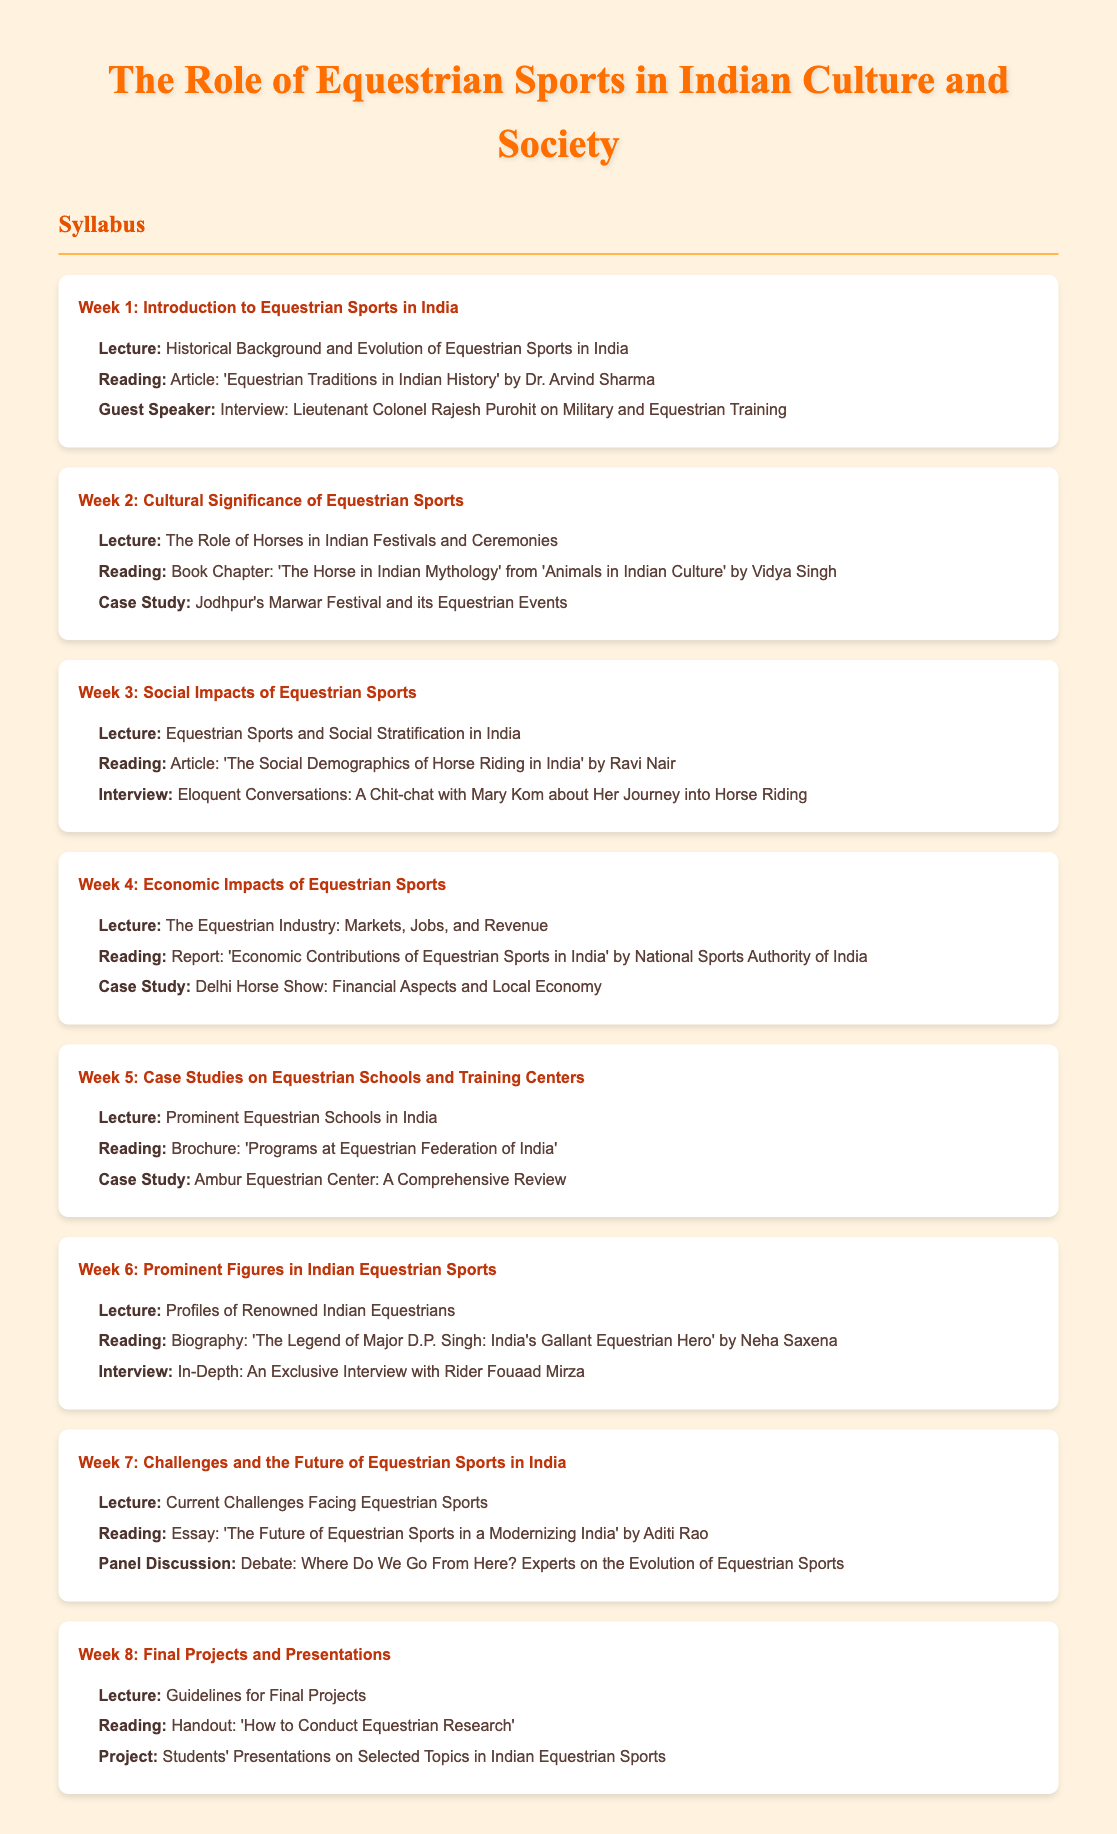What is the title of the syllabus? The title of the syllabus is prominently displayed at the beginning of the document, stating its main focus.
Answer: The Role of Equestrian Sports in Indian Culture and Society Who is the guest speaker in Week 1? The document lists a guest speaker for Week 1, highlighting individuals with expertise in equestrian sports.
Answer: Lieutenant Colonel Rajesh Purohit What is the case study in Week 2? A specific case study is provided in Week 2, showcasing an event relevant to equestrian sports in India.
Answer: Jodhpur's Marwar Festival and its Equestrian Events How many weeks are covered in the syllabus? The syllabus is organized into weeks, and the total number of weeks is explicitly stated.
Answer: 8 Which article is assigned in Week 3? The syllabus references a specific article related to social impacts in Week 3 that students are required to read.
Answer: The Social Demographics of Horse Riding in India What is the focus of Week 4's lecture? The theme of the lecture for Week 4 is outlined, indicating the economic aspects of equestrian sports.
Answer: The Equestrian Industry: Markets, Jobs, and Revenue Who is interviewed in Week 6? An interview subject is highlighted in Week 6, providing insight into the experiences of a notable figure in the field.
Answer: Rider Fouaad Mirza What reading material is provided for Week 7? A specific essay is mentioned that students will read in Week 7, concentrating on future challenges.
Answer: The Future of Equestrian Sports in a Modernizing India 